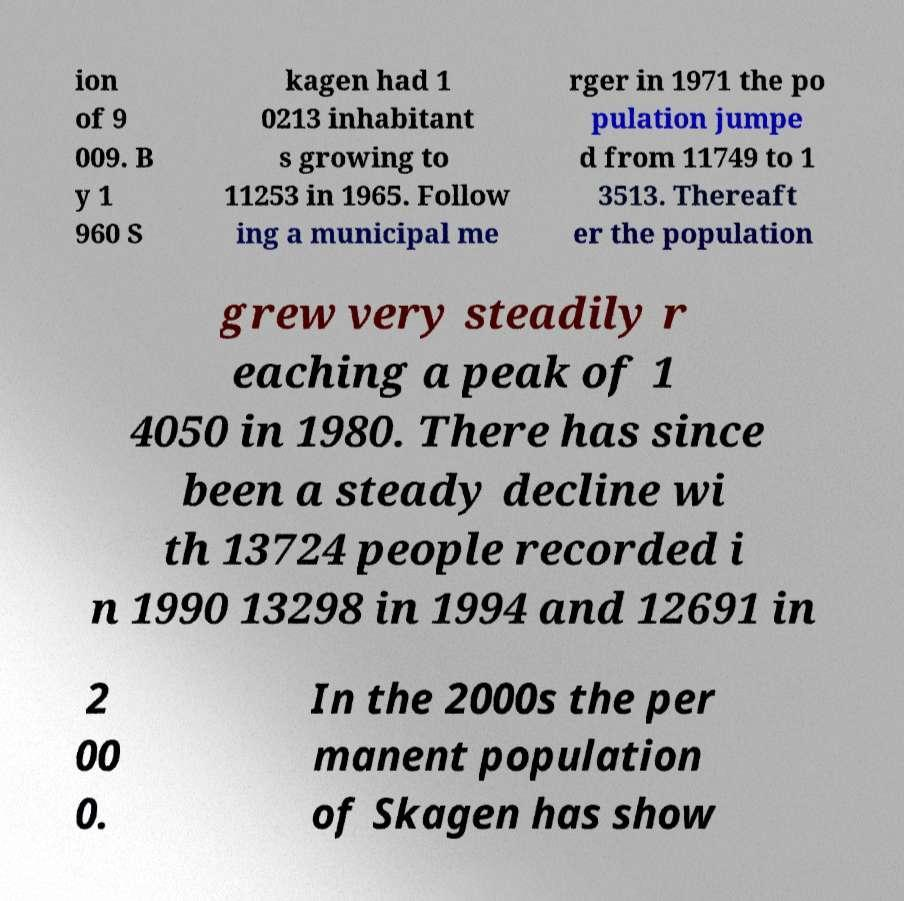I need the written content from this picture converted into text. Can you do that? ion of 9 009. B y 1 960 S kagen had 1 0213 inhabitant s growing to 11253 in 1965. Follow ing a municipal me rger in 1971 the po pulation jumpe d from 11749 to 1 3513. Thereaft er the population grew very steadily r eaching a peak of 1 4050 in 1980. There has since been a steady decline wi th 13724 people recorded i n 1990 13298 in 1994 and 12691 in 2 00 0. In the 2000s the per manent population of Skagen has show 